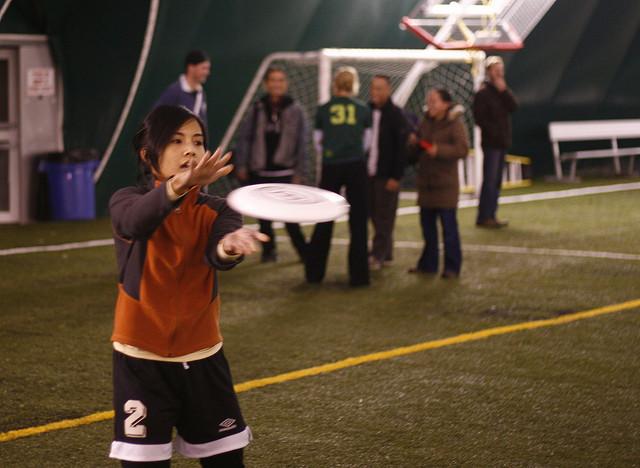What is this woman doing?
Be succinct. Playing frisbee. What is the girl playing?
Short answer required. Frisbee. What is the name of the field?
Write a very short answer. Soccer. What color is the frisbee?
Concise answer only. White. Is the boy going to play in a field?
Be succinct. Yes. Is the girl ready to throw the frisbee?
Quick response, please. No. Are there more than one frisbee?
Quick response, please. No. What color is the Frisbee?
Short answer required. White. What number is on the person's shirt?
Short answer required. 31. 